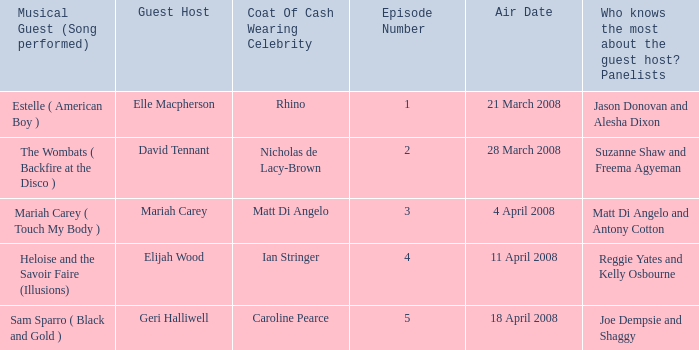Name the least number of episodes for the panelists of reggie yates and kelly osbourne 4.0. 